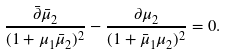<formula> <loc_0><loc_0><loc_500><loc_500>\frac { \bar { \partial } \bar { \mu } _ { 2 } } { ( 1 + \mu _ { 1 } \bar { \mu } _ { 2 } ) ^ { 2 } } - \frac { \partial \mu _ { 2 } } { ( 1 + \bar { \mu } _ { 1 } \mu _ { 2 } ) ^ { 2 } } = 0 .</formula> 